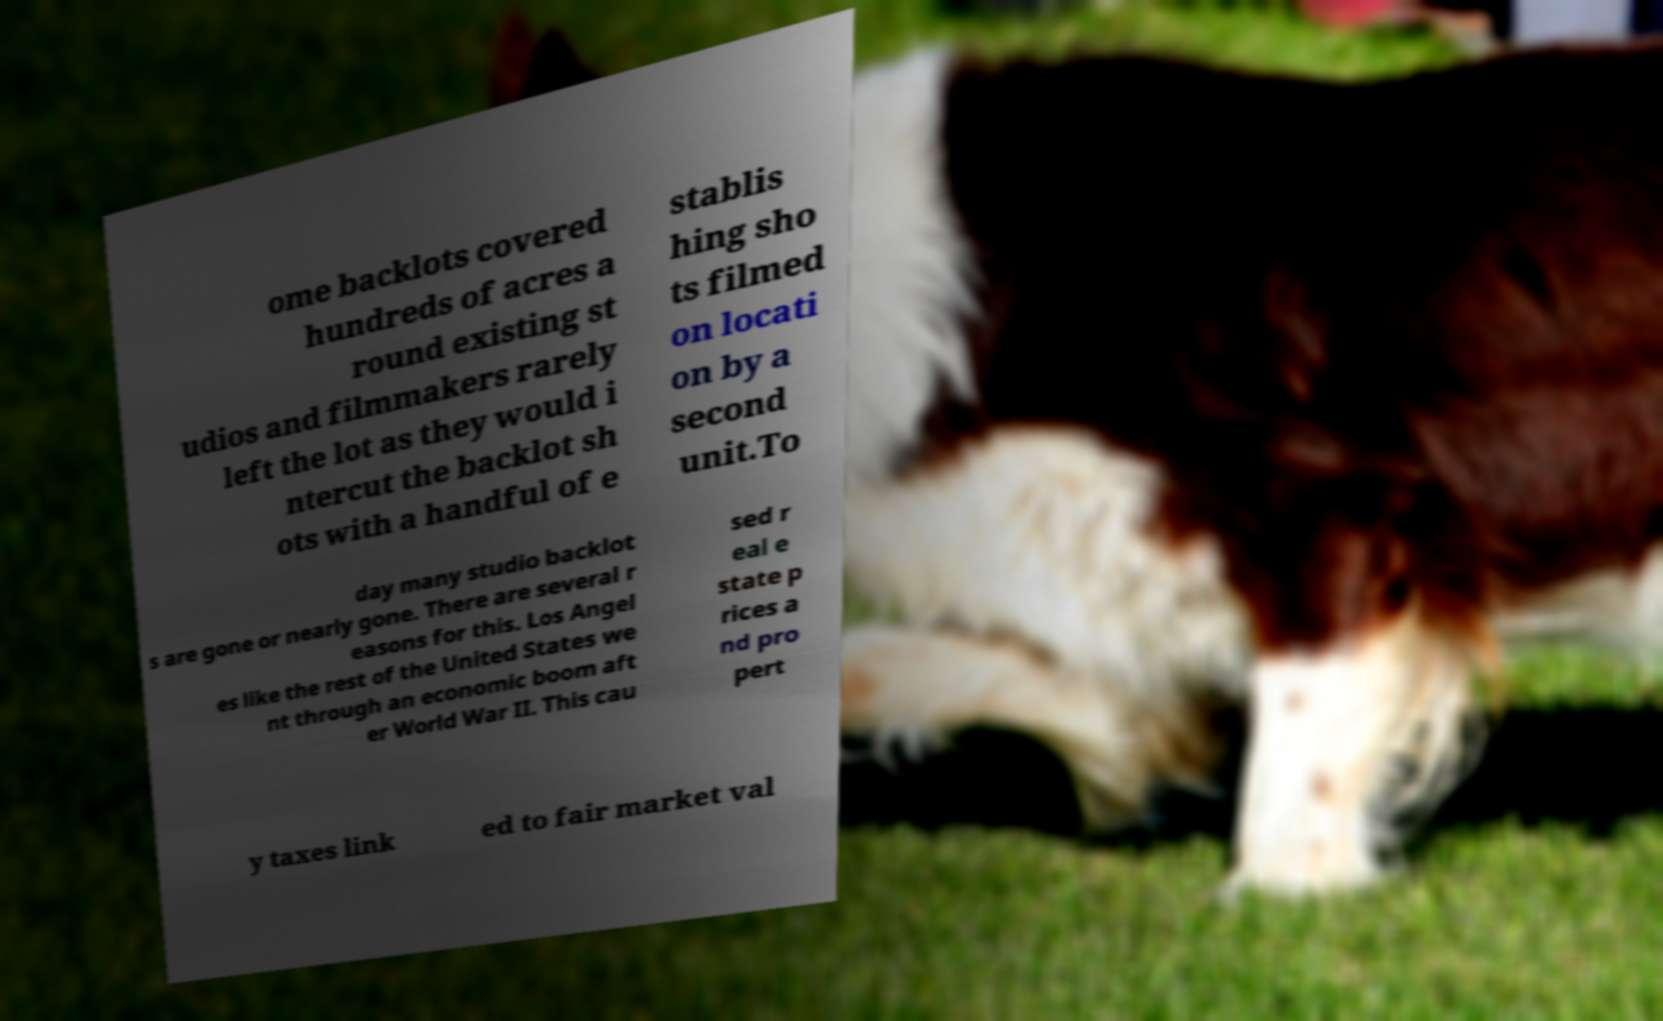Could you extract and type out the text from this image? ome backlots covered hundreds of acres a round existing st udios and filmmakers rarely left the lot as they would i ntercut the backlot sh ots with a handful of e stablis hing sho ts filmed on locati on by a second unit.To day many studio backlot s are gone or nearly gone. There are several r easons for this. Los Angel es like the rest of the United States we nt through an economic boom aft er World War II. This cau sed r eal e state p rices a nd pro pert y taxes link ed to fair market val 